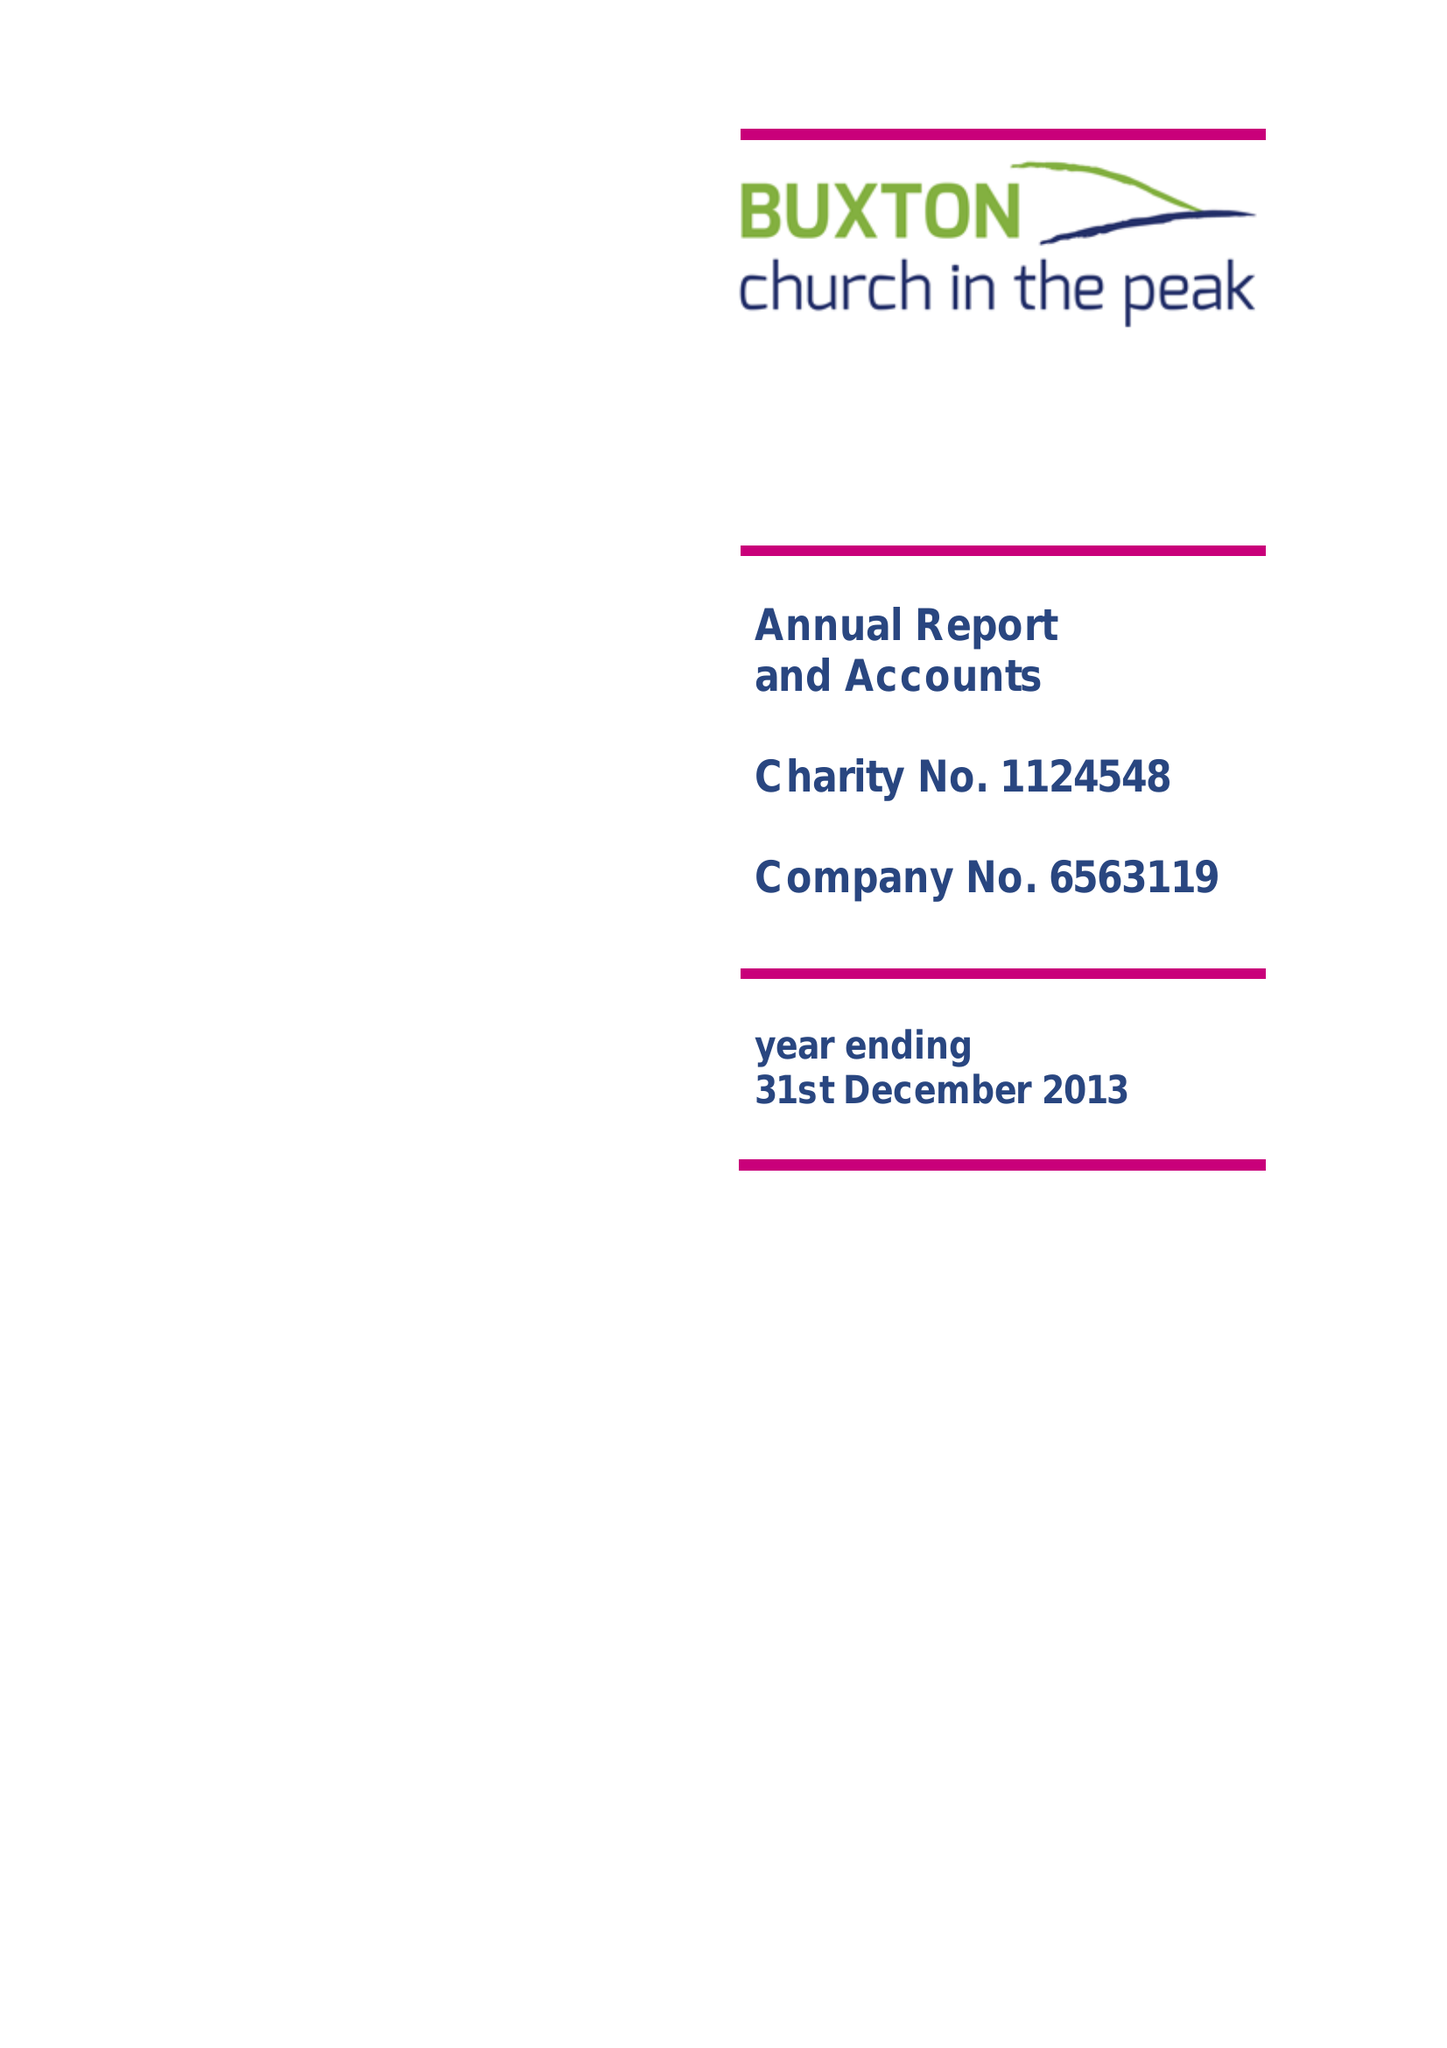What is the value for the address__street_line?
Answer the question using a single word or phrase. 116 MACCLESFIELD ROAD 